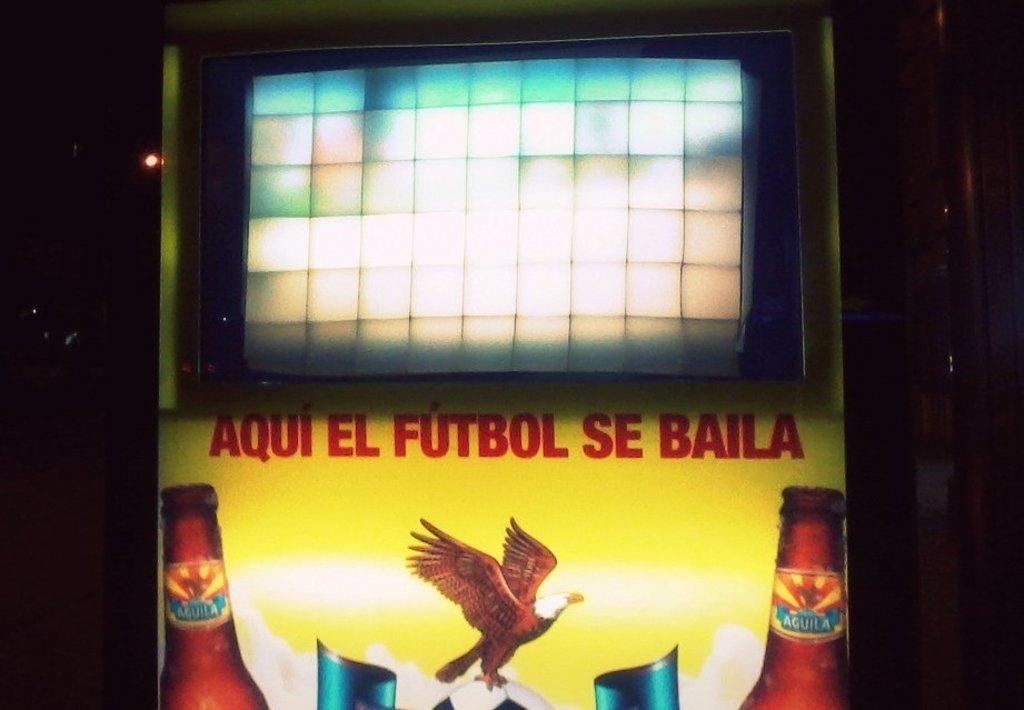Provide a one-sentence caption for the provided image. Vending machine written on the front in a soccer teams name Aqui EL FUTBOL SE BAILA. 